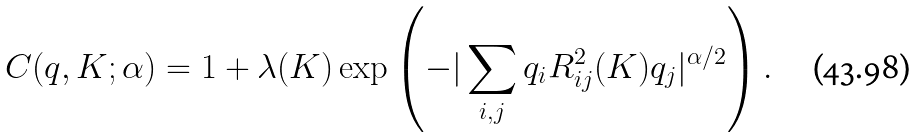Convert formula to latex. <formula><loc_0><loc_0><loc_500><loc_500>C ( q , K ; \alpha ) = 1 + \lambda ( K ) \exp \left ( - | \sum _ { i , j } q _ { i } R _ { i j } ^ { 2 } ( K ) q _ { j } | ^ { \alpha / 2 } \right ) .</formula> 